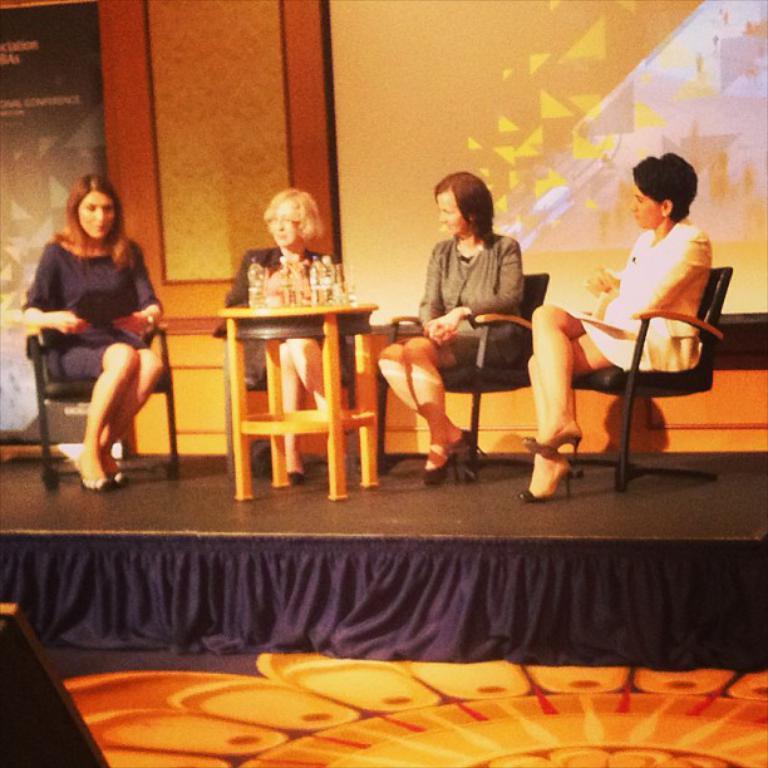Could you give a brief overview of what you see in this image? The picture is taken in a closed room where four women are sitting on the chairs on the stage and in front of them there is one small table where bottles are placed on it, behind them there is a screen, wall and a poster. At the left corner woman is wearing a purple dress and right corner woman is wearing a white dress. 